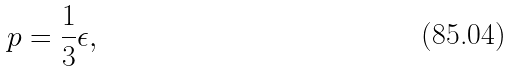<formula> <loc_0><loc_0><loc_500><loc_500>p = \frac { 1 } { 3 } \epsilon ,</formula> 